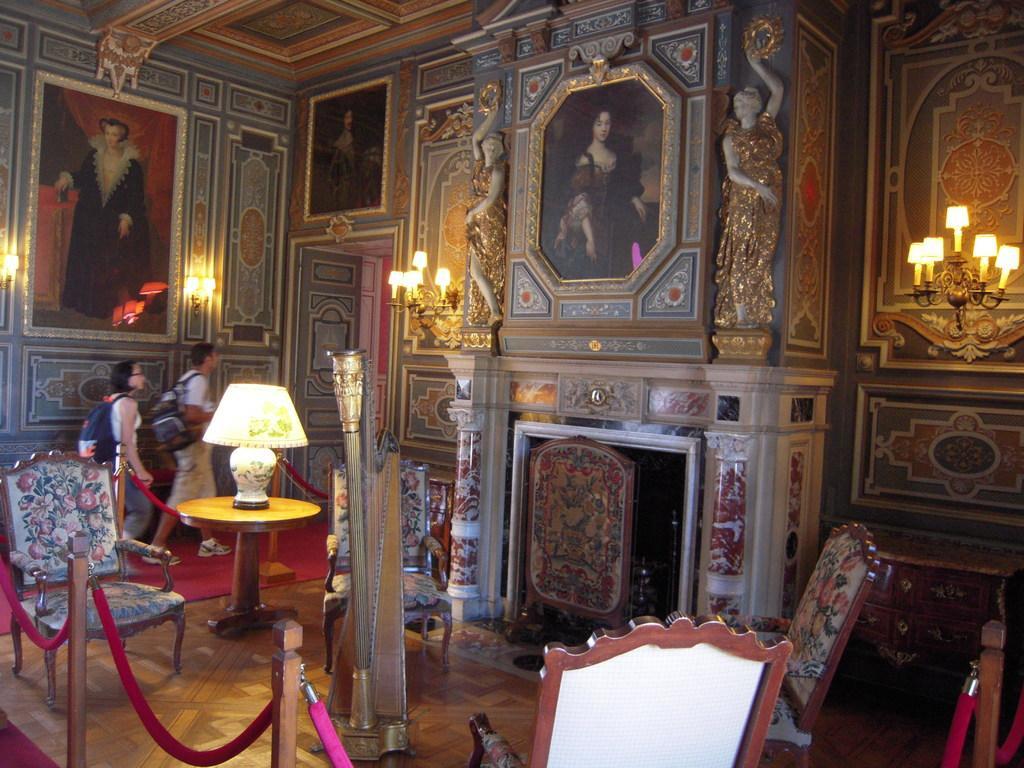Please provide a concise description of this image. This is a room with many paintings on the wall. There are two chandeliers on the wall. Also there are many chairs, table, on the table there is a table lamp and two persons wearing bag is walking on the red carpet. 